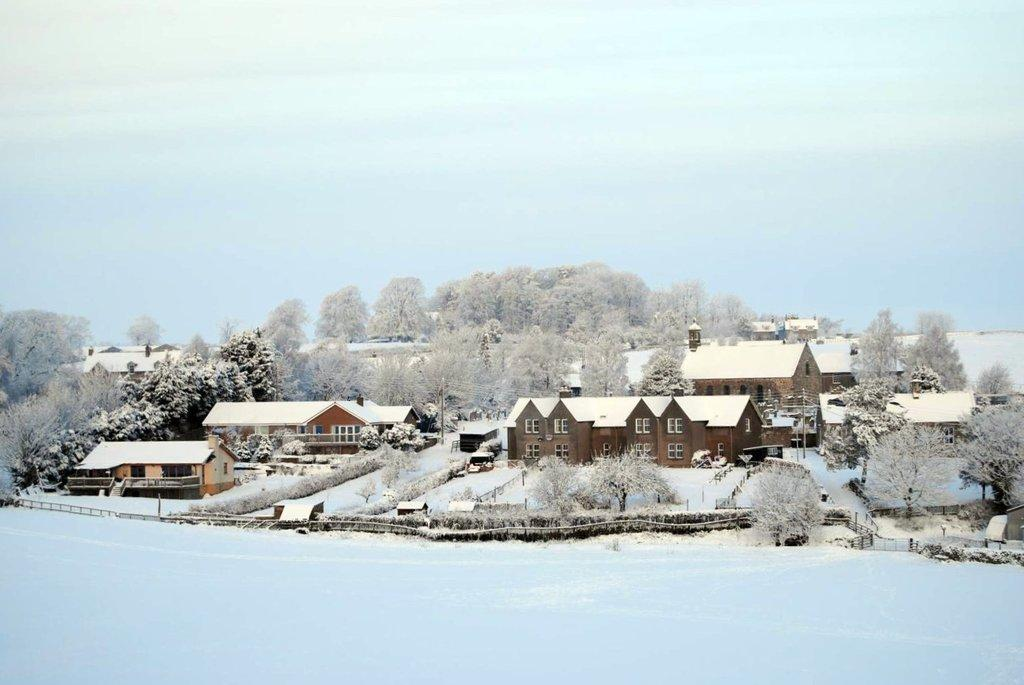What type of structures can be seen in the image? There are houses in the image. What is the condition of the trees in the image? The trees in the image are dry. What is covering the ground in the front bottom side of the image? There is a ground full of snow in the front bottom side of the image. What can be seen in the background of the image? There are trees visible in the background of the image. What type of star can be seen shining brightly in the image? There is no star visible in the image; it features houses, dry trees, and a snow-covered ground. What type of curtain is hanging in the window of the house in the image? There is no curtain visible in the image, as the windows of the houses are not shown in detail. 